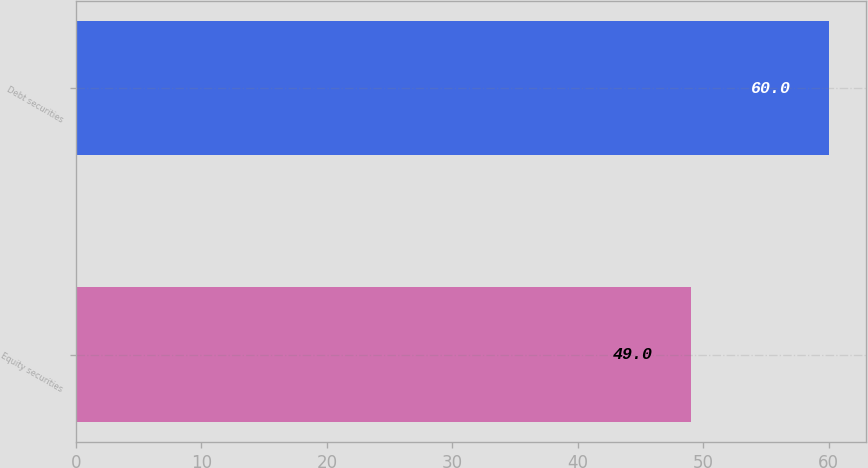Convert chart to OTSL. <chart><loc_0><loc_0><loc_500><loc_500><bar_chart><fcel>Equity securities<fcel>Debt securities<nl><fcel>49<fcel>60<nl></chart> 